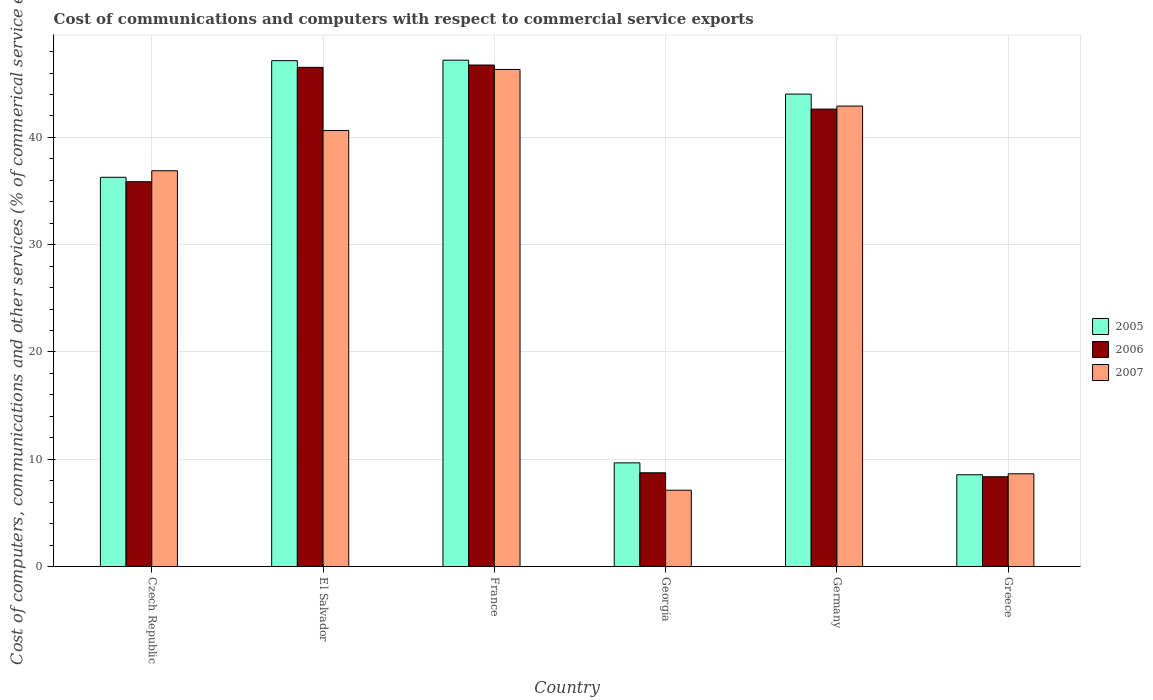How many different coloured bars are there?
Give a very brief answer. 3. Are the number of bars per tick equal to the number of legend labels?
Provide a short and direct response. Yes. What is the label of the 5th group of bars from the left?
Provide a short and direct response. Germany. In how many cases, is the number of bars for a given country not equal to the number of legend labels?
Your answer should be compact. 0. What is the cost of communications and computers in 2005 in France?
Provide a succinct answer. 47.19. Across all countries, what is the maximum cost of communications and computers in 2005?
Provide a short and direct response. 47.19. Across all countries, what is the minimum cost of communications and computers in 2006?
Give a very brief answer. 8.36. In which country was the cost of communications and computers in 2005 maximum?
Your response must be concise. France. In which country was the cost of communications and computers in 2007 minimum?
Your response must be concise. Georgia. What is the total cost of communications and computers in 2006 in the graph?
Offer a terse response. 188.87. What is the difference between the cost of communications and computers in 2007 in El Salvador and that in Georgia?
Give a very brief answer. 33.53. What is the difference between the cost of communications and computers in 2006 in Greece and the cost of communications and computers in 2007 in France?
Provide a succinct answer. -37.97. What is the average cost of communications and computers in 2005 per country?
Your response must be concise. 32.14. What is the difference between the cost of communications and computers of/in 2006 and cost of communications and computers of/in 2005 in France?
Make the answer very short. -0.45. In how many countries, is the cost of communications and computers in 2007 greater than 10 %?
Your answer should be very brief. 4. What is the ratio of the cost of communications and computers in 2007 in France to that in Georgia?
Make the answer very short. 6.52. Is the cost of communications and computers in 2005 in France less than that in Greece?
Your answer should be very brief. No. Is the difference between the cost of communications and computers in 2006 in El Salvador and Greece greater than the difference between the cost of communications and computers in 2005 in El Salvador and Greece?
Provide a short and direct response. No. What is the difference between the highest and the second highest cost of communications and computers in 2006?
Provide a short and direct response. 3.89. What is the difference between the highest and the lowest cost of communications and computers in 2005?
Offer a terse response. 38.64. Is the sum of the cost of communications and computers in 2006 in Germany and Greece greater than the maximum cost of communications and computers in 2005 across all countries?
Offer a terse response. Yes. Is it the case that in every country, the sum of the cost of communications and computers in 2007 and cost of communications and computers in 2006 is greater than the cost of communications and computers in 2005?
Offer a terse response. Yes. How many bars are there?
Your response must be concise. 18. How many countries are there in the graph?
Keep it short and to the point. 6. Does the graph contain any zero values?
Offer a very short reply. No. Where does the legend appear in the graph?
Provide a succinct answer. Center right. How are the legend labels stacked?
Keep it short and to the point. Vertical. What is the title of the graph?
Provide a short and direct response. Cost of communications and computers with respect to commercial service exports. What is the label or title of the X-axis?
Your answer should be very brief. Country. What is the label or title of the Y-axis?
Your response must be concise. Cost of computers, communications and other services (% of commerical service exports). What is the Cost of computers, communications and other services (% of commerical service exports) in 2005 in Czech Republic?
Provide a short and direct response. 36.28. What is the Cost of computers, communications and other services (% of commerical service exports) in 2006 in Czech Republic?
Your answer should be very brief. 35.87. What is the Cost of computers, communications and other services (% of commerical service exports) in 2007 in Czech Republic?
Offer a terse response. 36.89. What is the Cost of computers, communications and other services (% of commerical service exports) of 2005 in El Salvador?
Give a very brief answer. 47.15. What is the Cost of computers, communications and other services (% of commerical service exports) in 2006 in El Salvador?
Your answer should be very brief. 46.53. What is the Cost of computers, communications and other services (% of commerical service exports) of 2007 in El Salvador?
Provide a succinct answer. 40.64. What is the Cost of computers, communications and other services (% of commerical service exports) in 2005 in France?
Your answer should be very brief. 47.19. What is the Cost of computers, communications and other services (% of commerical service exports) in 2006 in France?
Offer a terse response. 46.74. What is the Cost of computers, communications and other services (% of commerical service exports) of 2007 in France?
Offer a terse response. 46.33. What is the Cost of computers, communications and other services (% of commerical service exports) of 2005 in Georgia?
Offer a very short reply. 9.66. What is the Cost of computers, communications and other services (% of commerical service exports) of 2006 in Georgia?
Your answer should be very brief. 8.74. What is the Cost of computers, communications and other services (% of commerical service exports) in 2007 in Georgia?
Provide a short and direct response. 7.11. What is the Cost of computers, communications and other services (% of commerical service exports) of 2005 in Germany?
Your answer should be compact. 44.03. What is the Cost of computers, communications and other services (% of commerical service exports) of 2006 in Germany?
Give a very brief answer. 42.64. What is the Cost of computers, communications and other services (% of commerical service exports) of 2007 in Germany?
Offer a very short reply. 42.92. What is the Cost of computers, communications and other services (% of commerical service exports) of 2005 in Greece?
Provide a succinct answer. 8.55. What is the Cost of computers, communications and other services (% of commerical service exports) in 2006 in Greece?
Give a very brief answer. 8.36. What is the Cost of computers, communications and other services (% of commerical service exports) in 2007 in Greece?
Offer a very short reply. 8.64. Across all countries, what is the maximum Cost of computers, communications and other services (% of commerical service exports) of 2005?
Your response must be concise. 47.19. Across all countries, what is the maximum Cost of computers, communications and other services (% of commerical service exports) of 2006?
Ensure brevity in your answer.  46.74. Across all countries, what is the maximum Cost of computers, communications and other services (% of commerical service exports) of 2007?
Ensure brevity in your answer.  46.33. Across all countries, what is the minimum Cost of computers, communications and other services (% of commerical service exports) in 2005?
Your answer should be compact. 8.55. Across all countries, what is the minimum Cost of computers, communications and other services (% of commerical service exports) of 2006?
Provide a succinct answer. 8.36. Across all countries, what is the minimum Cost of computers, communications and other services (% of commerical service exports) of 2007?
Offer a very short reply. 7.11. What is the total Cost of computers, communications and other services (% of commerical service exports) in 2005 in the graph?
Give a very brief answer. 192.87. What is the total Cost of computers, communications and other services (% of commerical service exports) in 2006 in the graph?
Offer a very short reply. 188.87. What is the total Cost of computers, communications and other services (% of commerical service exports) of 2007 in the graph?
Keep it short and to the point. 182.53. What is the difference between the Cost of computers, communications and other services (% of commerical service exports) in 2005 in Czech Republic and that in El Salvador?
Offer a very short reply. -10.87. What is the difference between the Cost of computers, communications and other services (% of commerical service exports) in 2006 in Czech Republic and that in El Salvador?
Offer a very short reply. -10.66. What is the difference between the Cost of computers, communications and other services (% of commerical service exports) in 2007 in Czech Republic and that in El Salvador?
Give a very brief answer. -3.75. What is the difference between the Cost of computers, communications and other services (% of commerical service exports) in 2005 in Czech Republic and that in France?
Your answer should be compact. -10.92. What is the difference between the Cost of computers, communications and other services (% of commerical service exports) of 2006 in Czech Republic and that in France?
Provide a succinct answer. -10.88. What is the difference between the Cost of computers, communications and other services (% of commerical service exports) in 2007 in Czech Republic and that in France?
Provide a short and direct response. -9.44. What is the difference between the Cost of computers, communications and other services (% of commerical service exports) of 2005 in Czech Republic and that in Georgia?
Ensure brevity in your answer.  26.62. What is the difference between the Cost of computers, communications and other services (% of commerical service exports) of 2006 in Czech Republic and that in Georgia?
Provide a short and direct response. 27.13. What is the difference between the Cost of computers, communications and other services (% of commerical service exports) in 2007 in Czech Republic and that in Georgia?
Ensure brevity in your answer.  29.78. What is the difference between the Cost of computers, communications and other services (% of commerical service exports) of 2005 in Czech Republic and that in Germany?
Your answer should be compact. -7.75. What is the difference between the Cost of computers, communications and other services (% of commerical service exports) in 2006 in Czech Republic and that in Germany?
Your answer should be very brief. -6.77. What is the difference between the Cost of computers, communications and other services (% of commerical service exports) in 2007 in Czech Republic and that in Germany?
Your answer should be very brief. -6.03. What is the difference between the Cost of computers, communications and other services (% of commerical service exports) in 2005 in Czech Republic and that in Greece?
Offer a very short reply. 27.73. What is the difference between the Cost of computers, communications and other services (% of commerical service exports) in 2006 in Czech Republic and that in Greece?
Give a very brief answer. 27.5. What is the difference between the Cost of computers, communications and other services (% of commerical service exports) in 2007 in Czech Republic and that in Greece?
Offer a very short reply. 28.25. What is the difference between the Cost of computers, communications and other services (% of commerical service exports) in 2005 in El Salvador and that in France?
Offer a terse response. -0.04. What is the difference between the Cost of computers, communications and other services (% of commerical service exports) of 2006 in El Salvador and that in France?
Ensure brevity in your answer.  -0.22. What is the difference between the Cost of computers, communications and other services (% of commerical service exports) in 2007 in El Salvador and that in France?
Give a very brief answer. -5.69. What is the difference between the Cost of computers, communications and other services (% of commerical service exports) in 2005 in El Salvador and that in Georgia?
Keep it short and to the point. 37.49. What is the difference between the Cost of computers, communications and other services (% of commerical service exports) in 2006 in El Salvador and that in Georgia?
Give a very brief answer. 37.79. What is the difference between the Cost of computers, communications and other services (% of commerical service exports) in 2007 in El Salvador and that in Georgia?
Your response must be concise. 33.53. What is the difference between the Cost of computers, communications and other services (% of commerical service exports) of 2005 in El Salvador and that in Germany?
Keep it short and to the point. 3.12. What is the difference between the Cost of computers, communications and other services (% of commerical service exports) in 2006 in El Salvador and that in Germany?
Offer a terse response. 3.89. What is the difference between the Cost of computers, communications and other services (% of commerical service exports) in 2007 in El Salvador and that in Germany?
Your answer should be very brief. -2.28. What is the difference between the Cost of computers, communications and other services (% of commerical service exports) in 2005 in El Salvador and that in Greece?
Make the answer very short. 38.6. What is the difference between the Cost of computers, communications and other services (% of commerical service exports) in 2006 in El Salvador and that in Greece?
Your answer should be very brief. 38.16. What is the difference between the Cost of computers, communications and other services (% of commerical service exports) in 2007 in El Salvador and that in Greece?
Provide a succinct answer. 32. What is the difference between the Cost of computers, communications and other services (% of commerical service exports) of 2005 in France and that in Georgia?
Your answer should be compact. 37.53. What is the difference between the Cost of computers, communications and other services (% of commerical service exports) of 2006 in France and that in Georgia?
Provide a short and direct response. 38.01. What is the difference between the Cost of computers, communications and other services (% of commerical service exports) in 2007 in France and that in Georgia?
Ensure brevity in your answer.  39.22. What is the difference between the Cost of computers, communications and other services (% of commerical service exports) of 2005 in France and that in Germany?
Provide a short and direct response. 3.16. What is the difference between the Cost of computers, communications and other services (% of commerical service exports) in 2006 in France and that in Germany?
Make the answer very short. 4.11. What is the difference between the Cost of computers, communications and other services (% of commerical service exports) of 2007 in France and that in Germany?
Offer a terse response. 3.41. What is the difference between the Cost of computers, communications and other services (% of commerical service exports) of 2005 in France and that in Greece?
Offer a terse response. 38.64. What is the difference between the Cost of computers, communications and other services (% of commerical service exports) of 2006 in France and that in Greece?
Ensure brevity in your answer.  38.38. What is the difference between the Cost of computers, communications and other services (% of commerical service exports) in 2007 in France and that in Greece?
Give a very brief answer. 37.69. What is the difference between the Cost of computers, communications and other services (% of commerical service exports) of 2005 in Georgia and that in Germany?
Give a very brief answer. -34.37. What is the difference between the Cost of computers, communications and other services (% of commerical service exports) in 2006 in Georgia and that in Germany?
Make the answer very short. -33.9. What is the difference between the Cost of computers, communications and other services (% of commerical service exports) in 2007 in Georgia and that in Germany?
Ensure brevity in your answer.  -35.81. What is the difference between the Cost of computers, communications and other services (% of commerical service exports) in 2005 in Georgia and that in Greece?
Your response must be concise. 1.11. What is the difference between the Cost of computers, communications and other services (% of commerical service exports) of 2006 in Georgia and that in Greece?
Make the answer very short. 0.37. What is the difference between the Cost of computers, communications and other services (% of commerical service exports) of 2007 in Georgia and that in Greece?
Your response must be concise. -1.53. What is the difference between the Cost of computers, communications and other services (% of commerical service exports) of 2005 in Germany and that in Greece?
Ensure brevity in your answer.  35.48. What is the difference between the Cost of computers, communications and other services (% of commerical service exports) of 2006 in Germany and that in Greece?
Offer a terse response. 34.27. What is the difference between the Cost of computers, communications and other services (% of commerical service exports) of 2007 in Germany and that in Greece?
Ensure brevity in your answer.  34.28. What is the difference between the Cost of computers, communications and other services (% of commerical service exports) of 2005 in Czech Republic and the Cost of computers, communications and other services (% of commerical service exports) of 2006 in El Salvador?
Offer a terse response. -10.25. What is the difference between the Cost of computers, communications and other services (% of commerical service exports) in 2005 in Czech Republic and the Cost of computers, communications and other services (% of commerical service exports) in 2007 in El Salvador?
Provide a succinct answer. -4.36. What is the difference between the Cost of computers, communications and other services (% of commerical service exports) in 2006 in Czech Republic and the Cost of computers, communications and other services (% of commerical service exports) in 2007 in El Salvador?
Give a very brief answer. -4.77. What is the difference between the Cost of computers, communications and other services (% of commerical service exports) of 2005 in Czech Republic and the Cost of computers, communications and other services (% of commerical service exports) of 2006 in France?
Your answer should be very brief. -10.46. What is the difference between the Cost of computers, communications and other services (% of commerical service exports) in 2005 in Czech Republic and the Cost of computers, communications and other services (% of commerical service exports) in 2007 in France?
Your answer should be very brief. -10.05. What is the difference between the Cost of computers, communications and other services (% of commerical service exports) of 2006 in Czech Republic and the Cost of computers, communications and other services (% of commerical service exports) of 2007 in France?
Keep it short and to the point. -10.46. What is the difference between the Cost of computers, communications and other services (% of commerical service exports) in 2005 in Czech Republic and the Cost of computers, communications and other services (% of commerical service exports) in 2006 in Georgia?
Give a very brief answer. 27.54. What is the difference between the Cost of computers, communications and other services (% of commerical service exports) of 2005 in Czech Republic and the Cost of computers, communications and other services (% of commerical service exports) of 2007 in Georgia?
Give a very brief answer. 29.17. What is the difference between the Cost of computers, communications and other services (% of commerical service exports) in 2006 in Czech Republic and the Cost of computers, communications and other services (% of commerical service exports) in 2007 in Georgia?
Your response must be concise. 28.76. What is the difference between the Cost of computers, communications and other services (% of commerical service exports) in 2005 in Czech Republic and the Cost of computers, communications and other services (% of commerical service exports) in 2006 in Germany?
Provide a short and direct response. -6.36. What is the difference between the Cost of computers, communications and other services (% of commerical service exports) in 2005 in Czech Republic and the Cost of computers, communications and other services (% of commerical service exports) in 2007 in Germany?
Ensure brevity in your answer.  -6.64. What is the difference between the Cost of computers, communications and other services (% of commerical service exports) of 2006 in Czech Republic and the Cost of computers, communications and other services (% of commerical service exports) of 2007 in Germany?
Provide a succinct answer. -7.05. What is the difference between the Cost of computers, communications and other services (% of commerical service exports) in 2005 in Czech Republic and the Cost of computers, communications and other services (% of commerical service exports) in 2006 in Greece?
Make the answer very short. 27.91. What is the difference between the Cost of computers, communications and other services (% of commerical service exports) in 2005 in Czech Republic and the Cost of computers, communications and other services (% of commerical service exports) in 2007 in Greece?
Give a very brief answer. 27.64. What is the difference between the Cost of computers, communications and other services (% of commerical service exports) in 2006 in Czech Republic and the Cost of computers, communications and other services (% of commerical service exports) in 2007 in Greece?
Keep it short and to the point. 27.23. What is the difference between the Cost of computers, communications and other services (% of commerical service exports) of 2005 in El Salvador and the Cost of computers, communications and other services (% of commerical service exports) of 2006 in France?
Offer a very short reply. 0.41. What is the difference between the Cost of computers, communications and other services (% of commerical service exports) of 2005 in El Salvador and the Cost of computers, communications and other services (% of commerical service exports) of 2007 in France?
Provide a succinct answer. 0.82. What is the difference between the Cost of computers, communications and other services (% of commerical service exports) of 2006 in El Salvador and the Cost of computers, communications and other services (% of commerical service exports) of 2007 in France?
Provide a short and direct response. 0.19. What is the difference between the Cost of computers, communications and other services (% of commerical service exports) of 2005 in El Salvador and the Cost of computers, communications and other services (% of commerical service exports) of 2006 in Georgia?
Provide a short and direct response. 38.41. What is the difference between the Cost of computers, communications and other services (% of commerical service exports) of 2005 in El Salvador and the Cost of computers, communications and other services (% of commerical service exports) of 2007 in Georgia?
Your response must be concise. 40.04. What is the difference between the Cost of computers, communications and other services (% of commerical service exports) in 2006 in El Salvador and the Cost of computers, communications and other services (% of commerical service exports) in 2007 in Georgia?
Ensure brevity in your answer.  39.42. What is the difference between the Cost of computers, communications and other services (% of commerical service exports) in 2005 in El Salvador and the Cost of computers, communications and other services (% of commerical service exports) in 2006 in Germany?
Your answer should be compact. 4.51. What is the difference between the Cost of computers, communications and other services (% of commerical service exports) of 2005 in El Salvador and the Cost of computers, communications and other services (% of commerical service exports) of 2007 in Germany?
Give a very brief answer. 4.23. What is the difference between the Cost of computers, communications and other services (% of commerical service exports) of 2006 in El Salvador and the Cost of computers, communications and other services (% of commerical service exports) of 2007 in Germany?
Keep it short and to the point. 3.61. What is the difference between the Cost of computers, communications and other services (% of commerical service exports) of 2005 in El Salvador and the Cost of computers, communications and other services (% of commerical service exports) of 2006 in Greece?
Keep it short and to the point. 38.78. What is the difference between the Cost of computers, communications and other services (% of commerical service exports) of 2005 in El Salvador and the Cost of computers, communications and other services (% of commerical service exports) of 2007 in Greece?
Offer a terse response. 38.51. What is the difference between the Cost of computers, communications and other services (% of commerical service exports) in 2006 in El Salvador and the Cost of computers, communications and other services (% of commerical service exports) in 2007 in Greece?
Make the answer very short. 37.89. What is the difference between the Cost of computers, communications and other services (% of commerical service exports) in 2005 in France and the Cost of computers, communications and other services (% of commerical service exports) in 2006 in Georgia?
Ensure brevity in your answer.  38.46. What is the difference between the Cost of computers, communications and other services (% of commerical service exports) in 2005 in France and the Cost of computers, communications and other services (% of commerical service exports) in 2007 in Georgia?
Make the answer very short. 40.09. What is the difference between the Cost of computers, communications and other services (% of commerical service exports) in 2006 in France and the Cost of computers, communications and other services (% of commerical service exports) in 2007 in Georgia?
Provide a succinct answer. 39.64. What is the difference between the Cost of computers, communications and other services (% of commerical service exports) of 2005 in France and the Cost of computers, communications and other services (% of commerical service exports) of 2006 in Germany?
Provide a succinct answer. 4.56. What is the difference between the Cost of computers, communications and other services (% of commerical service exports) in 2005 in France and the Cost of computers, communications and other services (% of commerical service exports) in 2007 in Germany?
Your response must be concise. 4.28. What is the difference between the Cost of computers, communications and other services (% of commerical service exports) in 2006 in France and the Cost of computers, communications and other services (% of commerical service exports) in 2007 in Germany?
Give a very brief answer. 3.83. What is the difference between the Cost of computers, communications and other services (% of commerical service exports) of 2005 in France and the Cost of computers, communications and other services (% of commerical service exports) of 2006 in Greece?
Your answer should be compact. 38.83. What is the difference between the Cost of computers, communications and other services (% of commerical service exports) in 2005 in France and the Cost of computers, communications and other services (% of commerical service exports) in 2007 in Greece?
Offer a very short reply. 38.55. What is the difference between the Cost of computers, communications and other services (% of commerical service exports) in 2006 in France and the Cost of computers, communications and other services (% of commerical service exports) in 2007 in Greece?
Provide a short and direct response. 38.1. What is the difference between the Cost of computers, communications and other services (% of commerical service exports) of 2005 in Georgia and the Cost of computers, communications and other services (% of commerical service exports) of 2006 in Germany?
Make the answer very short. -32.98. What is the difference between the Cost of computers, communications and other services (% of commerical service exports) in 2005 in Georgia and the Cost of computers, communications and other services (% of commerical service exports) in 2007 in Germany?
Ensure brevity in your answer.  -33.26. What is the difference between the Cost of computers, communications and other services (% of commerical service exports) in 2006 in Georgia and the Cost of computers, communications and other services (% of commerical service exports) in 2007 in Germany?
Ensure brevity in your answer.  -34.18. What is the difference between the Cost of computers, communications and other services (% of commerical service exports) in 2005 in Georgia and the Cost of computers, communications and other services (% of commerical service exports) in 2006 in Greece?
Make the answer very short. 1.3. What is the difference between the Cost of computers, communications and other services (% of commerical service exports) in 2005 in Georgia and the Cost of computers, communications and other services (% of commerical service exports) in 2007 in Greece?
Provide a short and direct response. 1.02. What is the difference between the Cost of computers, communications and other services (% of commerical service exports) in 2006 in Georgia and the Cost of computers, communications and other services (% of commerical service exports) in 2007 in Greece?
Ensure brevity in your answer.  0.1. What is the difference between the Cost of computers, communications and other services (% of commerical service exports) of 2005 in Germany and the Cost of computers, communications and other services (% of commerical service exports) of 2006 in Greece?
Your answer should be very brief. 35.67. What is the difference between the Cost of computers, communications and other services (% of commerical service exports) in 2005 in Germany and the Cost of computers, communications and other services (% of commerical service exports) in 2007 in Greece?
Offer a very short reply. 35.39. What is the difference between the Cost of computers, communications and other services (% of commerical service exports) of 2006 in Germany and the Cost of computers, communications and other services (% of commerical service exports) of 2007 in Greece?
Provide a short and direct response. 34. What is the average Cost of computers, communications and other services (% of commerical service exports) in 2005 per country?
Your answer should be compact. 32.14. What is the average Cost of computers, communications and other services (% of commerical service exports) in 2006 per country?
Your answer should be very brief. 31.48. What is the average Cost of computers, communications and other services (% of commerical service exports) in 2007 per country?
Provide a succinct answer. 30.42. What is the difference between the Cost of computers, communications and other services (% of commerical service exports) in 2005 and Cost of computers, communications and other services (% of commerical service exports) in 2006 in Czech Republic?
Offer a terse response. 0.41. What is the difference between the Cost of computers, communications and other services (% of commerical service exports) in 2005 and Cost of computers, communications and other services (% of commerical service exports) in 2007 in Czech Republic?
Your answer should be very brief. -0.61. What is the difference between the Cost of computers, communications and other services (% of commerical service exports) in 2006 and Cost of computers, communications and other services (% of commerical service exports) in 2007 in Czech Republic?
Your answer should be compact. -1.02. What is the difference between the Cost of computers, communications and other services (% of commerical service exports) of 2005 and Cost of computers, communications and other services (% of commerical service exports) of 2006 in El Salvador?
Keep it short and to the point. 0.62. What is the difference between the Cost of computers, communications and other services (% of commerical service exports) of 2005 and Cost of computers, communications and other services (% of commerical service exports) of 2007 in El Salvador?
Offer a very short reply. 6.51. What is the difference between the Cost of computers, communications and other services (% of commerical service exports) in 2006 and Cost of computers, communications and other services (% of commerical service exports) in 2007 in El Salvador?
Ensure brevity in your answer.  5.89. What is the difference between the Cost of computers, communications and other services (% of commerical service exports) in 2005 and Cost of computers, communications and other services (% of commerical service exports) in 2006 in France?
Offer a very short reply. 0.45. What is the difference between the Cost of computers, communications and other services (% of commerical service exports) in 2005 and Cost of computers, communications and other services (% of commerical service exports) in 2007 in France?
Give a very brief answer. 0.86. What is the difference between the Cost of computers, communications and other services (% of commerical service exports) in 2006 and Cost of computers, communications and other services (% of commerical service exports) in 2007 in France?
Make the answer very short. 0.41. What is the difference between the Cost of computers, communications and other services (% of commerical service exports) of 2005 and Cost of computers, communications and other services (% of commerical service exports) of 2006 in Georgia?
Provide a succinct answer. 0.93. What is the difference between the Cost of computers, communications and other services (% of commerical service exports) in 2005 and Cost of computers, communications and other services (% of commerical service exports) in 2007 in Georgia?
Give a very brief answer. 2.55. What is the difference between the Cost of computers, communications and other services (% of commerical service exports) of 2006 and Cost of computers, communications and other services (% of commerical service exports) of 2007 in Georgia?
Keep it short and to the point. 1.63. What is the difference between the Cost of computers, communications and other services (% of commerical service exports) in 2005 and Cost of computers, communications and other services (% of commerical service exports) in 2006 in Germany?
Ensure brevity in your answer.  1.4. What is the difference between the Cost of computers, communications and other services (% of commerical service exports) of 2005 and Cost of computers, communications and other services (% of commerical service exports) of 2007 in Germany?
Ensure brevity in your answer.  1.11. What is the difference between the Cost of computers, communications and other services (% of commerical service exports) of 2006 and Cost of computers, communications and other services (% of commerical service exports) of 2007 in Germany?
Offer a very short reply. -0.28. What is the difference between the Cost of computers, communications and other services (% of commerical service exports) of 2005 and Cost of computers, communications and other services (% of commerical service exports) of 2006 in Greece?
Provide a succinct answer. 0.19. What is the difference between the Cost of computers, communications and other services (% of commerical service exports) in 2005 and Cost of computers, communications and other services (% of commerical service exports) in 2007 in Greece?
Give a very brief answer. -0.09. What is the difference between the Cost of computers, communications and other services (% of commerical service exports) in 2006 and Cost of computers, communications and other services (% of commerical service exports) in 2007 in Greece?
Offer a terse response. -0.28. What is the ratio of the Cost of computers, communications and other services (% of commerical service exports) of 2005 in Czech Republic to that in El Salvador?
Your response must be concise. 0.77. What is the ratio of the Cost of computers, communications and other services (% of commerical service exports) in 2006 in Czech Republic to that in El Salvador?
Your response must be concise. 0.77. What is the ratio of the Cost of computers, communications and other services (% of commerical service exports) of 2007 in Czech Republic to that in El Salvador?
Offer a very short reply. 0.91. What is the ratio of the Cost of computers, communications and other services (% of commerical service exports) in 2005 in Czech Republic to that in France?
Keep it short and to the point. 0.77. What is the ratio of the Cost of computers, communications and other services (% of commerical service exports) in 2006 in Czech Republic to that in France?
Your answer should be compact. 0.77. What is the ratio of the Cost of computers, communications and other services (% of commerical service exports) of 2007 in Czech Republic to that in France?
Give a very brief answer. 0.8. What is the ratio of the Cost of computers, communications and other services (% of commerical service exports) in 2005 in Czech Republic to that in Georgia?
Offer a terse response. 3.76. What is the ratio of the Cost of computers, communications and other services (% of commerical service exports) of 2006 in Czech Republic to that in Georgia?
Ensure brevity in your answer.  4.11. What is the ratio of the Cost of computers, communications and other services (% of commerical service exports) in 2007 in Czech Republic to that in Georgia?
Your answer should be compact. 5.19. What is the ratio of the Cost of computers, communications and other services (% of commerical service exports) of 2005 in Czech Republic to that in Germany?
Provide a short and direct response. 0.82. What is the ratio of the Cost of computers, communications and other services (% of commerical service exports) in 2006 in Czech Republic to that in Germany?
Ensure brevity in your answer.  0.84. What is the ratio of the Cost of computers, communications and other services (% of commerical service exports) in 2007 in Czech Republic to that in Germany?
Your answer should be very brief. 0.86. What is the ratio of the Cost of computers, communications and other services (% of commerical service exports) of 2005 in Czech Republic to that in Greece?
Give a very brief answer. 4.24. What is the ratio of the Cost of computers, communications and other services (% of commerical service exports) of 2006 in Czech Republic to that in Greece?
Keep it short and to the point. 4.29. What is the ratio of the Cost of computers, communications and other services (% of commerical service exports) in 2007 in Czech Republic to that in Greece?
Ensure brevity in your answer.  4.27. What is the ratio of the Cost of computers, communications and other services (% of commerical service exports) in 2005 in El Salvador to that in France?
Your answer should be very brief. 1. What is the ratio of the Cost of computers, communications and other services (% of commerical service exports) of 2007 in El Salvador to that in France?
Keep it short and to the point. 0.88. What is the ratio of the Cost of computers, communications and other services (% of commerical service exports) in 2005 in El Salvador to that in Georgia?
Keep it short and to the point. 4.88. What is the ratio of the Cost of computers, communications and other services (% of commerical service exports) of 2006 in El Salvador to that in Georgia?
Your answer should be very brief. 5.33. What is the ratio of the Cost of computers, communications and other services (% of commerical service exports) in 2007 in El Salvador to that in Georgia?
Offer a very short reply. 5.72. What is the ratio of the Cost of computers, communications and other services (% of commerical service exports) of 2005 in El Salvador to that in Germany?
Your answer should be very brief. 1.07. What is the ratio of the Cost of computers, communications and other services (% of commerical service exports) of 2006 in El Salvador to that in Germany?
Your response must be concise. 1.09. What is the ratio of the Cost of computers, communications and other services (% of commerical service exports) of 2007 in El Salvador to that in Germany?
Your answer should be compact. 0.95. What is the ratio of the Cost of computers, communications and other services (% of commerical service exports) of 2005 in El Salvador to that in Greece?
Make the answer very short. 5.51. What is the ratio of the Cost of computers, communications and other services (% of commerical service exports) in 2006 in El Salvador to that in Greece?
Offer a terse response. 5.56. What is the ratio of the Cost of computers, communications and other services (% of commerical service exports) in 2007 in El Salvador to that in Greece?
Make the answer very short. 4.7. What is the ratio of the Cost of computers, communications and other services (% of commerical service exports) in 2005 in France to that in Georgia?
Offer a very short reply. 4.89. What is the ratio of the Cost of computers, communications and other services (% of commerical service exports) in 2006 in France to that in Georgia?
Keep it short and to the point. 5.35. What is the ratio of the Cost of computers, communications and other services (% of commerical service exports) of 2007 in France to that in Georgia?
Make the answer very short. 6.52. What is the ratio of the Cost of computers, communications and other services (% of commerical service exports) in 2005 in France to that in Germany?
Make the answer very short. 1.07. What is the ratio of the Cost of computers, communications and other services (% of commerical service exports) of 2006 in France to that in Germany?
Provide a succinct answer. 1.1. What is the ratio of the Cost of computers, communications and other services (% of commerical service exports) of 2007 in France to that in Germany?
Your answer should be very brief. 1.08. What is the ratio of the Cost of computers, communications and other services (% of commerical service exports) in 2005 in France to that in Greece?
Provide a short and direct response. 5.52. What is the ratio of the Cost of computers, communications and other services (% of commerical service exports) in 2006 in France to that in Greece?
Provide a succinct answer. 5.59. What is the ratio of the Cost of computers, communications and other services (% of commerical service exports) in 2007 in France to that in Greece?
Your answer should be compact. 5.36. What is the ratio of the Cost of computers, communications and other services (% of commerical service exports) in 2005 in Georgia to that in Germany?
Offer a very short reply. 0.22. What is the ratio of the Cost of computers, communications and other services (% of commerical service exports) in 2006 in Georgia to that in Germany?
Ensure brevity in your answer.  0.2. What is the ratio of the Cost of computers, communications and other services (% of commerical service exports) of 2007 in Georgia to that in Germany?
Your answer should be compact. 0.17. What is the ratio of the Cost of computers, communications and other services (% of commerical service exports) of 2005 in Georgia to that in Greece?
Provide a short and direct response. 1.13. What is the ratio of the Cost of computers, communications and other services (% of commerical service exports) of 2006 in Georgia to that in Greece?
Your answer should be compact. 1.04. What is the ratio of the Cost of computers, communications and other services (% of commerical service exports) of 2007 in Georgia to that in Greece?
Provide a succinct answer. 0.82. What is the ratio of the Cost of computers, communications and other services (% of commerical service exports) of 2005 in Germany to that in Greece?
Make the answer very short. 5.15. What is the ratio of the Cost of computers, communications and other services (% of commerical service exports) of 2006 in Germany to that in Greece?
Provide a succinct answer. 5.1. What is the ratio of the Cost of computers, communications and other services (% of commerical service exports) in 2007 in Germany to that in Greece?
Provide a short and direct response. 4.97. What is the difference between the highest and the second highest Cost of computers, communications and other services (% of commerical service exports) in 2005?
Make the answer very short. 0.04. What is the difference between the highest and the second highest Cost of computers, communications and other services (% of commerical service exports) of 2006?
Offer a terse response. 0.22. What is the difference between the highest and the second highest Cost of computers, communications and other services (% of commerical service exports) of 2007?
Offer a terse response. 3.41. What is the difference between the highest and the lowest Cost of computers, communications and other services (% of commerical service exports) of 2005?
Keep it short and to the point. 38.64. What is the difference between the highest and the lowest Cost of computers, communications and other services (% of commerical service exports) of 2006?
Provide a succinct answer. 38.38. What is the difference between the highest and the lowest Cost of computers, communications and other services (% of commerical service exports) of 2007?
Offer a very short reply. 39.22. 